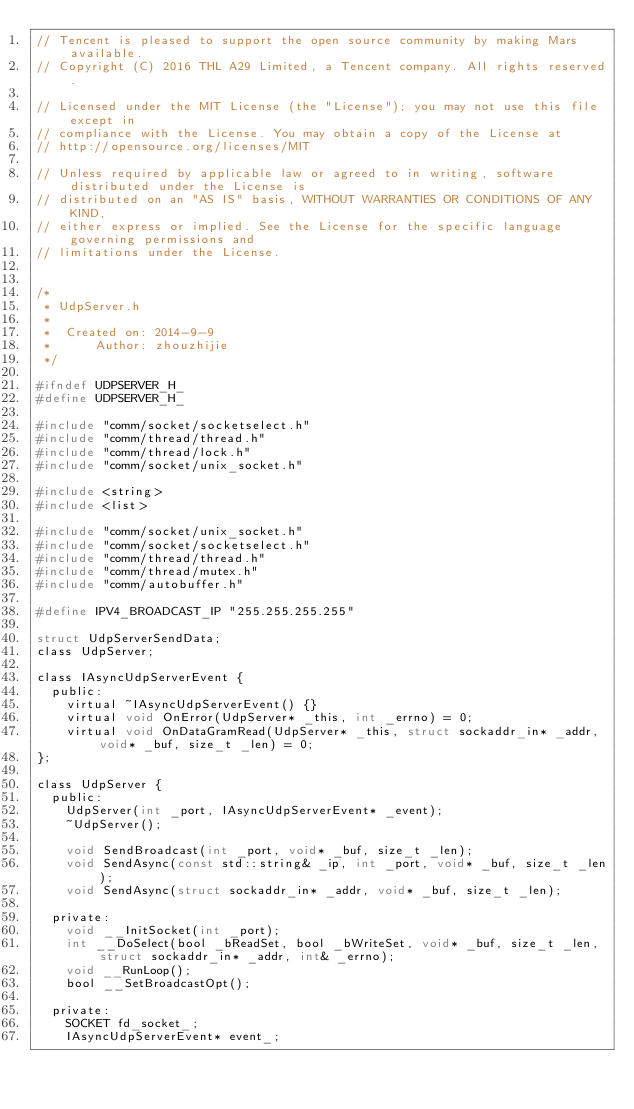Convert code to text. <code><loc_0><loc_0><loc_500><loc_500><_C_>// Tencent is pleased to support the open source community by making Mars available.
// Copyright (C) 2016 THL A29 Limited, a Tencent company. All rights reserved.

// Licensed under the MIT License (the "License"); you may not use this file except in 
// compliance with the License. You may obtain a copy of the License at
// http://opensource.org/licenses/MIT

// Unless required by applicable law or agreed to in writing, software distributed under the License is
// distributed on an "AS IS" basis, WITHOUT WARRANTIES OR CONDITIONS OF ANY KIND,
// either express or implied. See the License for the specific language governing permissions and
// limitations under the License.


/*
 * UdpServer.h
 *
 *  Created on: 2014-9-9
 *      Author: zhouzhijie
 */

#ifndef UDPSERVER_H_
#define UDPSERVER_H_

#include "comm/socket/socketselect.h"
#include "comm/thread/thread.h"
#include "comm/thread/lock.h"
#include "comm/socket/unix_socket.h"

#include <string>
#include <list>

#include "comm/socket/unix_socket.h"
#include "comm/socket/socketselect.h"
#include "comm/thread/thread.h"
#include "comm/thread/mutex.h"
#include "comm/autobuffer.h"

#define IPV4_BROADCAST_IP "255.255.255.255"

struct UdpServerSendData;
class UdpServer;

class IAsyncUdpServerEvent {
  public:
    virtual ~IAsyncUdpServerEvent() {}
    virtual void OnError(UdpServer* _this, int _errno) = 0;
    virtual void OnDataGramRead(UdpServer* _this, struct sockaddr_in* _addr, void* _buf, size_t _len) = 0;
};

class UdpServer {
  public:
    UdpServer(int _port, IAsyncUdpServerEvent* _event);
    ~UdpServer();

    void SendBroadcast(int _port, void* _buf, size_t _len);
    void SendAsync(const std::string& _ip, int _port, void* _buf, size_t _len);
    void SendAsync(struct sockaddr_in* _addr, void* _buf, size_t _len);

  private:
    void __InitSocket(int _port);
    int __DoSelect(bool _bReadSet, bool _bWriteSet, void* _buf, size_t _len, struct sockaddr_in* _addr, int& _errno);
    void __RunLoop();
    bool __SetBroadcastOpt();

  private:
    SOCKET fd_socket_;
    IAsyncUdpServerEvent* event_;
</code> 